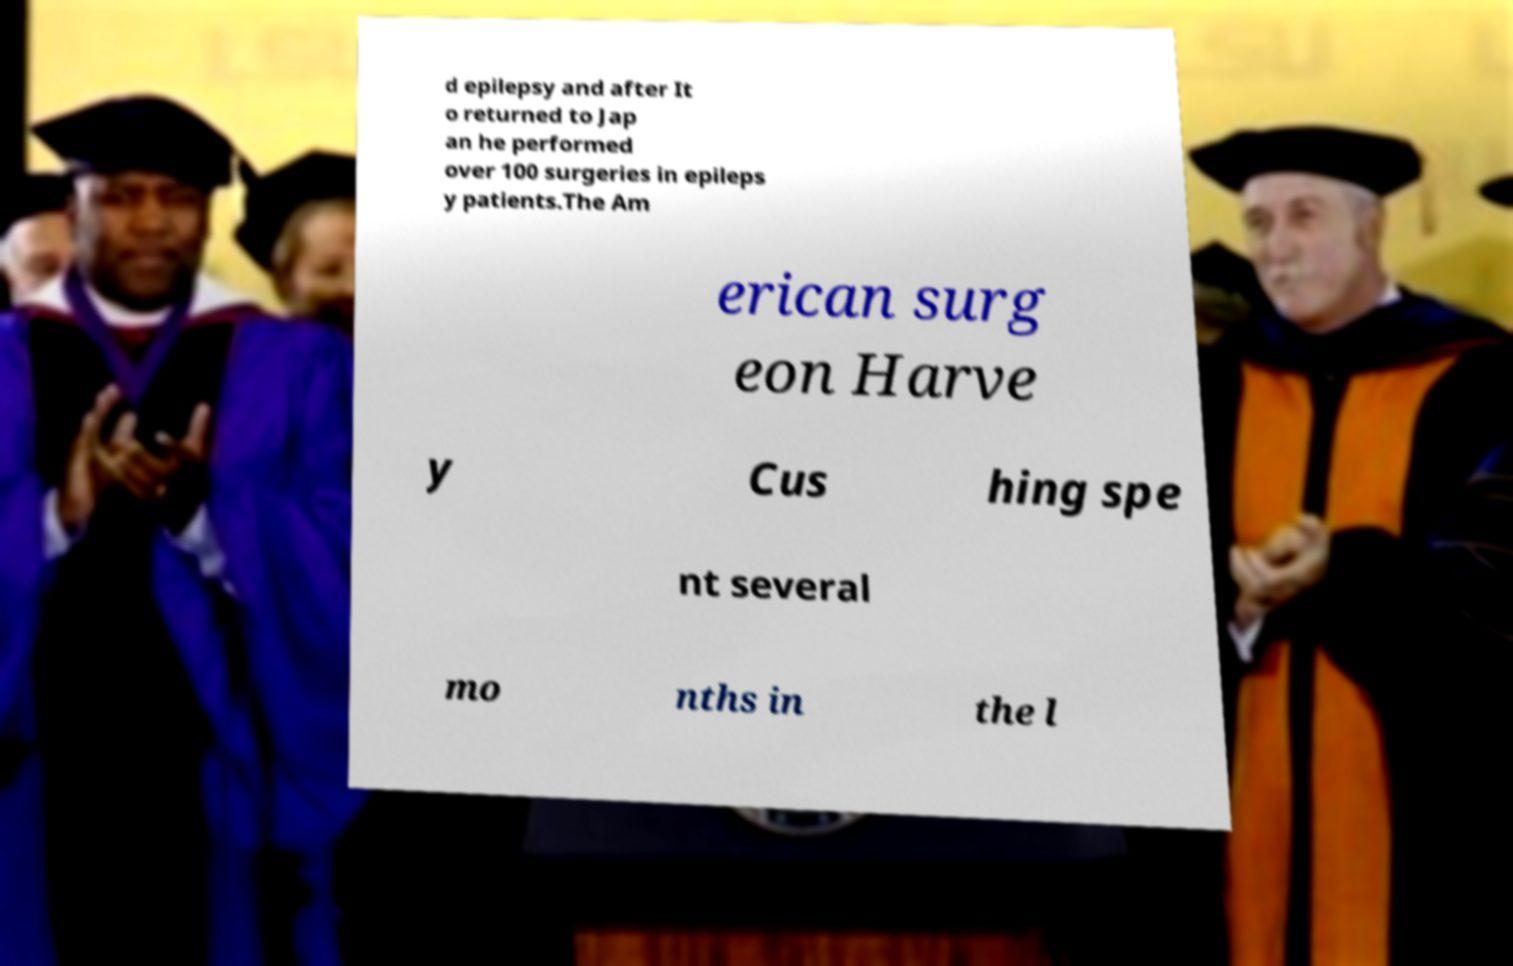Could you assist in decoding the text presented in this image and type it out clearly? d epilepsy and after It o returned to Jap an he performed over 100 surgeries in epileps y patients.The Am erican surg eon Harve y Cus hing spe nt several mo nths in the l 